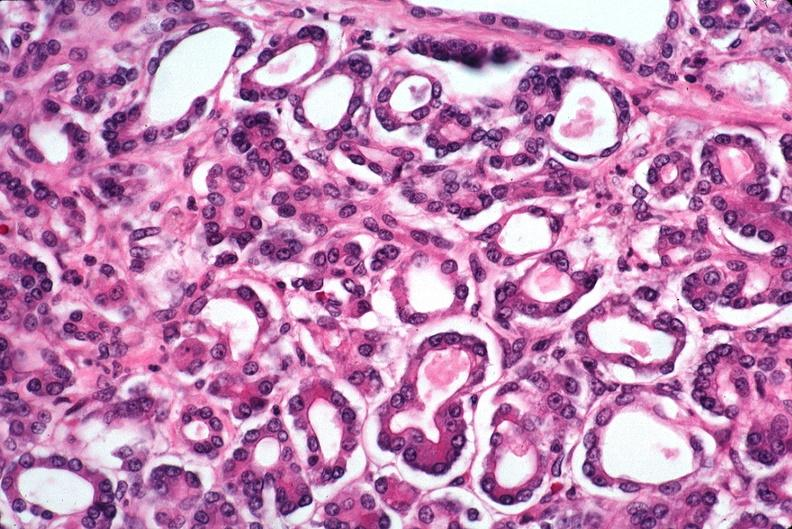where is this?
Answer the question using a single word or phrase. Pancreas 